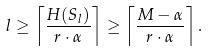<formula> <loc_0><loc_0><loc_500><loc_500>l \geq \left \lceil \frac { H ( S _ { l } ) } { r \cdot \alpha } \right \rceil \geq \left \lceil \frac { M - \alpha } { r \cdot \alpha } \right \rceil .</formula> 